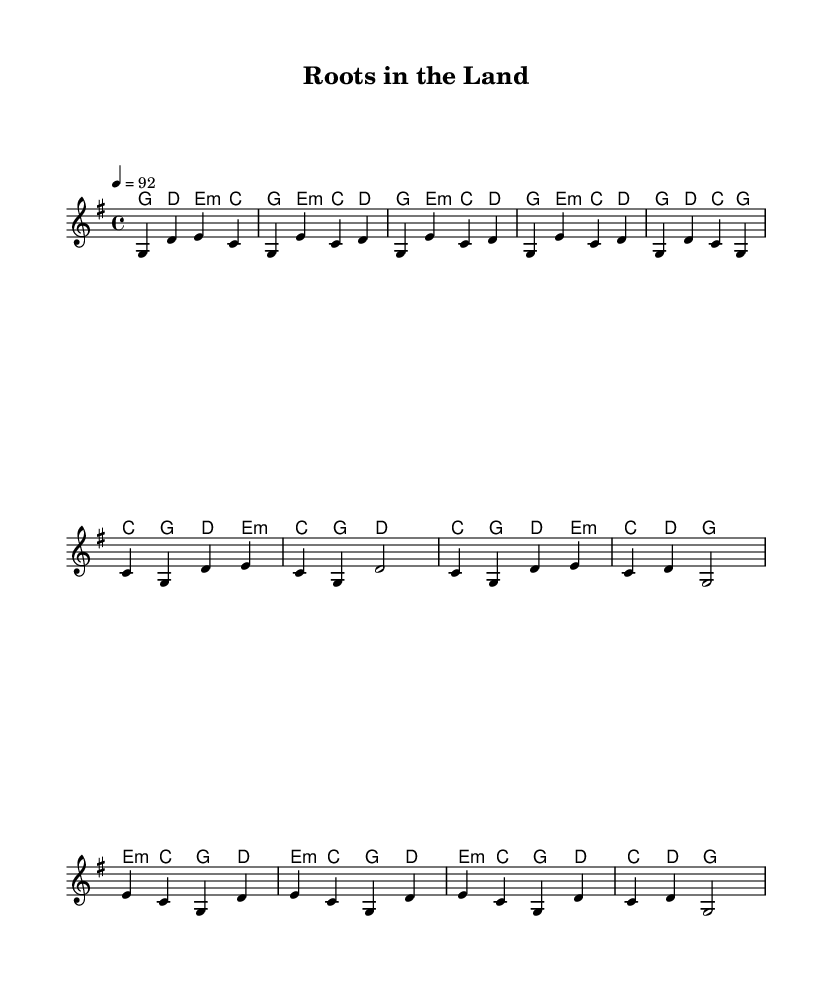What is the key signature of this music? The key signature is G major, which has one sharp (F#). This can be determined by looking for the key signature indication, which is found at the beginning of the staff.
Answer: G major What is the time signature of this music? The time signature is 4/4, indicated at the beginning of the score. This means there are four beats in each measure and the quarter note receives one beat.
Answer: 4/4 What is the tempo marking of this music? The tempo marking is 92, noted at the top of the score where "4 = 92" is indicated. This tells the performer to play at a speed of 92 beats per minute.
Answer: 92 How many measures are in the chorus section? The chorus section consists of four measures, which can be counted by identifying the segments that are separated by bar lines. Each group of notes that is closed off by a vertical line represents one measure.
Answer: 4 What chord follows the first melody note in the introduction? The first chord that accompanies the initial melody note (G) in the introduction is G major, as indicated in the chord chart below the staff.
Answer: G major What is a recurring theme in the lyrics suggested by the music structure? The music structure suggests a theme of connectivity to ancestral land and nature, illustrated through the harmony and melodic progression, characteristic of Americana-influenced country music. This inference is drawn from the title "Roots in the Land" and the overall harmonies that invoke natural imagery.
Answer: Connection to nature How many distinct sections are present in the music? There are three distinct sections in the music: the verse, chorus, and bridge. Each section is defined by its unique melody and harmony, contributing to the overall structure of the piece. Counting these parts gives the number of sections.
Answer: 3 